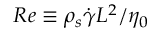Convert formula to latex. <formula><loc_0><loc_0><loc_500><loc_500>R e \equiv \rho _ { s } \dot { \gamma } L ^ { 2 } / \eta _ { 0 }</formula> 